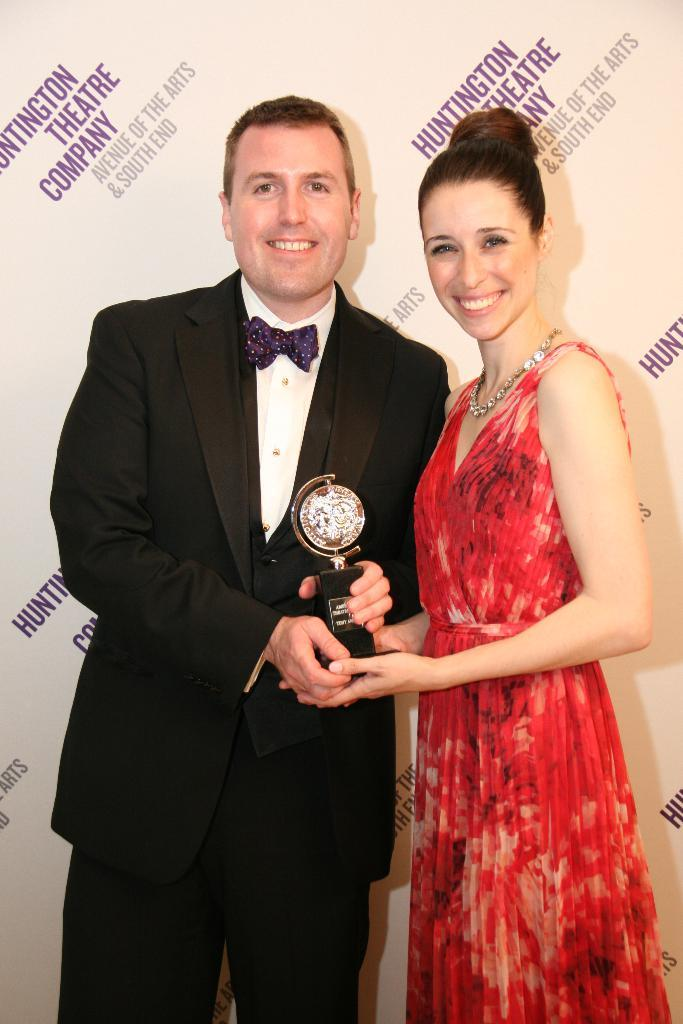<image>
Relay a brief, clear account of the picture shown. two people shake hands and hold a trophy by the Huntington Theater Company sign 